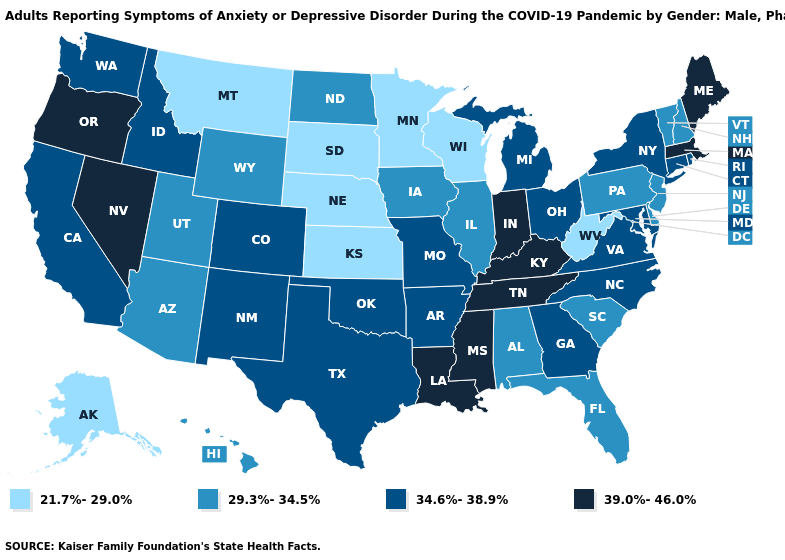Does Washington have a higher value than New Jersey?
Concise answer only. Yes. Does the first symbol in the legend represent the smallest category?
Concise answer only. Yes. Name the states that have a value in the range 39.0%-46.0%?
Short answer required. Indiana, Kentucky, Louisiana, Maine, Massachusetts, Mississippi, Nevada, Oregon, Tennessee. Does Mississippi have the highest value in the South?
Be succinct. Yes. What is the value of Virginia?
Answer briefly. 34.6%-38.9%. Among the states that border Montana , which have the lowest value?
Concise answer only. South Dakota. Does Oregon have the same value as Connecticut?
Keep it brief. No. Name the states that have a value in the range 39.0%-46.0%?
Answer briefly. Indiana, Kentucky, Louisiana, Maine, Massachusetts, Mississippi, Nevada, Oregon, Tennessee. Does Mississippi have the highest value in the USA?
Give a very brief answer. Yes. What is the highest value in states that border Virginia?
Quick response, please. 39.0%-46.0%. Among the states that border Minnesota , which have the highest value?
Write a very short answer. Iowa, North Dakota. Which states hav the highest value in the South?
Keep it brief. Kentucky, Louisiana, Mississippi, Tennessee. What is the highest value in states that border Nevada?
Write a very short answer. 39.0%-46.0%. Among the states that border Oklahoma , does Missouri have the highest value?
Quick response, please. Yes. Name the states that have a value in the range 34.6%-38.9%?
Give a very brief answer. Arkansas, California, Colorado, Connecticut, Georgia, Idaho, Maryland, Michigan, Missouri, New Mexico, New York, North Carolina, Ohio, Oklahoma, Rhode Island, Texas, Virginia, Washington. 